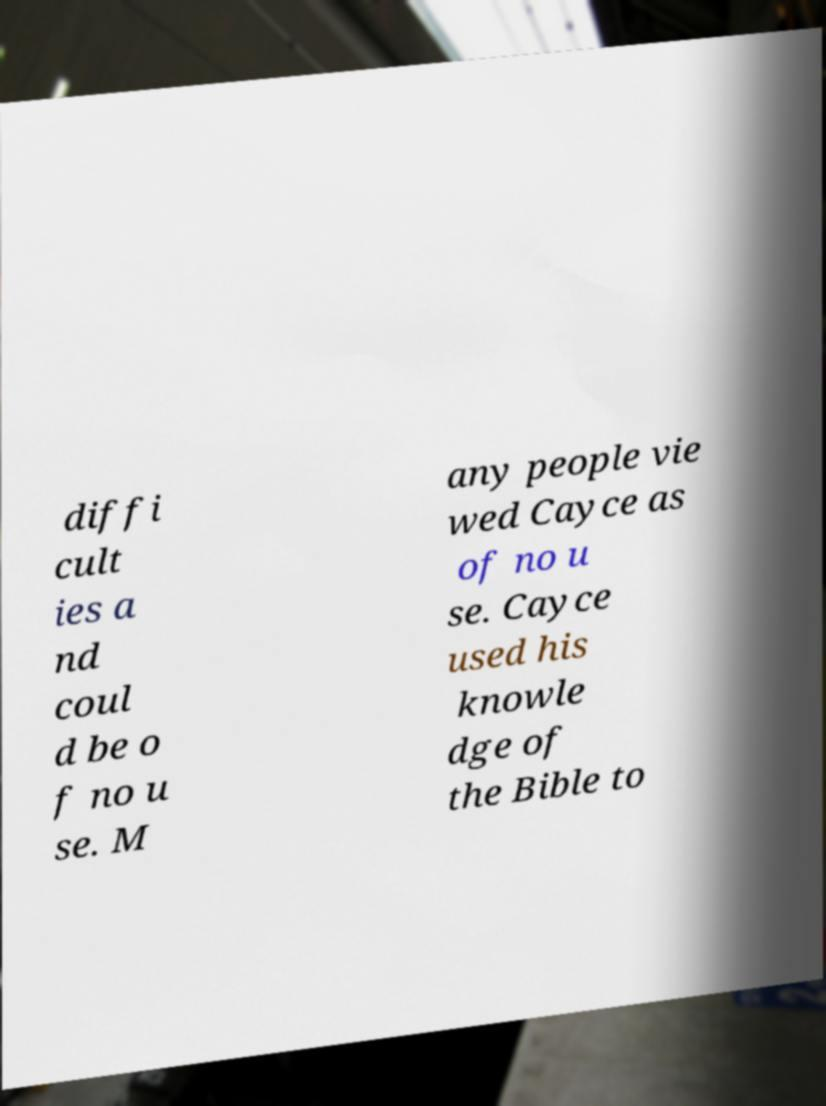Please identify and transcribe the text found in this image. diffi cult ies a nd coul d be o f no u se. M any people vie wed Cayce as of no u se. Cayce used his knowle dge of the Bible to 